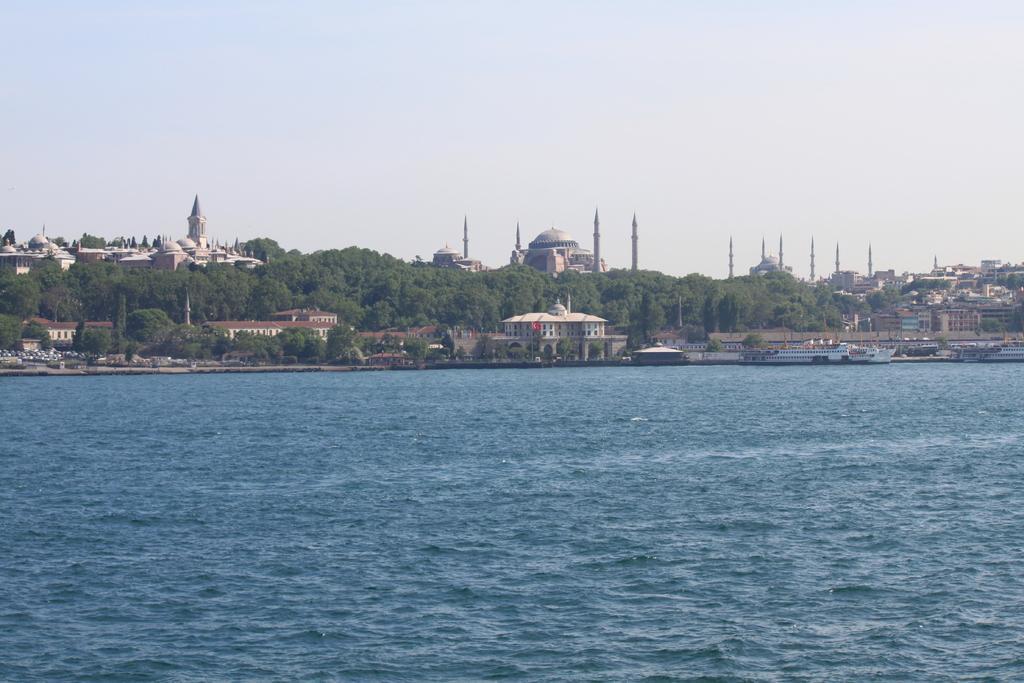Could you give a brief overview of what you see in this image? This picture shows about the blue sea water in the front. Behind we can see some building and some trees. In the background there is a big mosque with dome and tower. 